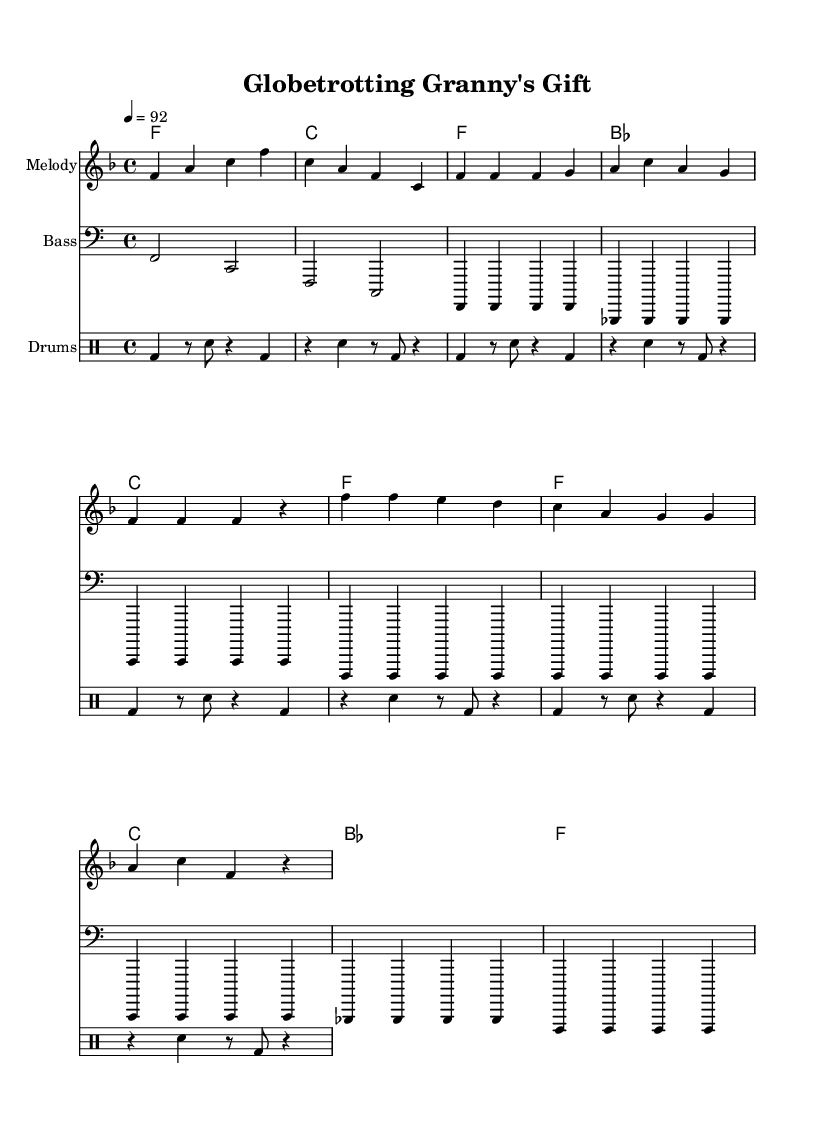What is the key signature of this music? The key signature is F major, which has one flat (B flat). The key is indicated by the key signature at the beginning of the staff.
Answer: F major What is the time signature of the piece? The time signature is 4/4, which is typically indicated at the beginning of the staff. This means there are four beats in each measure.
Answer: 4/4 What is the tempo marking for this piece? The tempo marking indicates that the piece should be played at a speed of 92 beats per minute, as shown in the tempo indication.
Answer: 92 How many measures are in each section of the music? The music consists of 8 measures in the intro, 8 measures in the verse, and 8 measures in the chorus. This can be counted in the grouped measures as seen in the sheet music layout.
Answer: 8 What type of lyrics are used in this rap? The lyrics include a storytelling element, describing a grandmother's adventures and gifts from exotic places, which is common in rap narratives. This can be inferred from the content of the lyrics written in the lyric section of the score.
Answer: Storytelling What instrument is used for the melody? The melody is written for a general staff without specifying an instrument but is usually played on a lead instrument like a flute or synthesizer in rap compositions. The context clues suggest it is a melodic line on a solo instrument.
Answer: Melody What is the role of the drum pattern in this rap composition? The drum pattern provides the rhythmic foundation, essential for driving the rap forward and enhancing the percussive elements typical in rap music, as shown in the dedicated drum staff.
Answer: Rhythmic foundation 